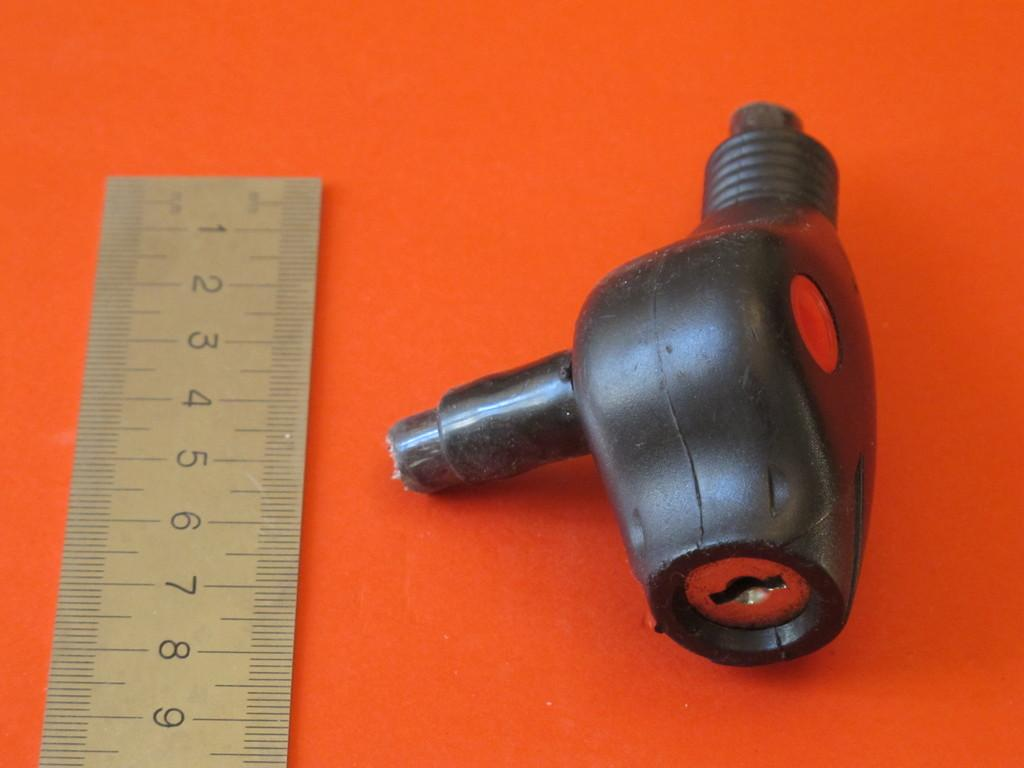<image>
Write a terse but informative summary of the picture. Black and red device being measured on a ruler that goes up to the number 9. 